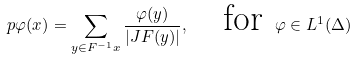Convert formula to latex. <formula><loc_0><loc_0><loc_500><loc_500>\ p \varphi ( x ) = \sum _ { y \in F ^ { - 1 } x } \frac { \varphi ( y ) } { | J F ( y ) | } , \quad \text {for } \varphi \in L ^ { 1 } ( \Delta )</formula> 